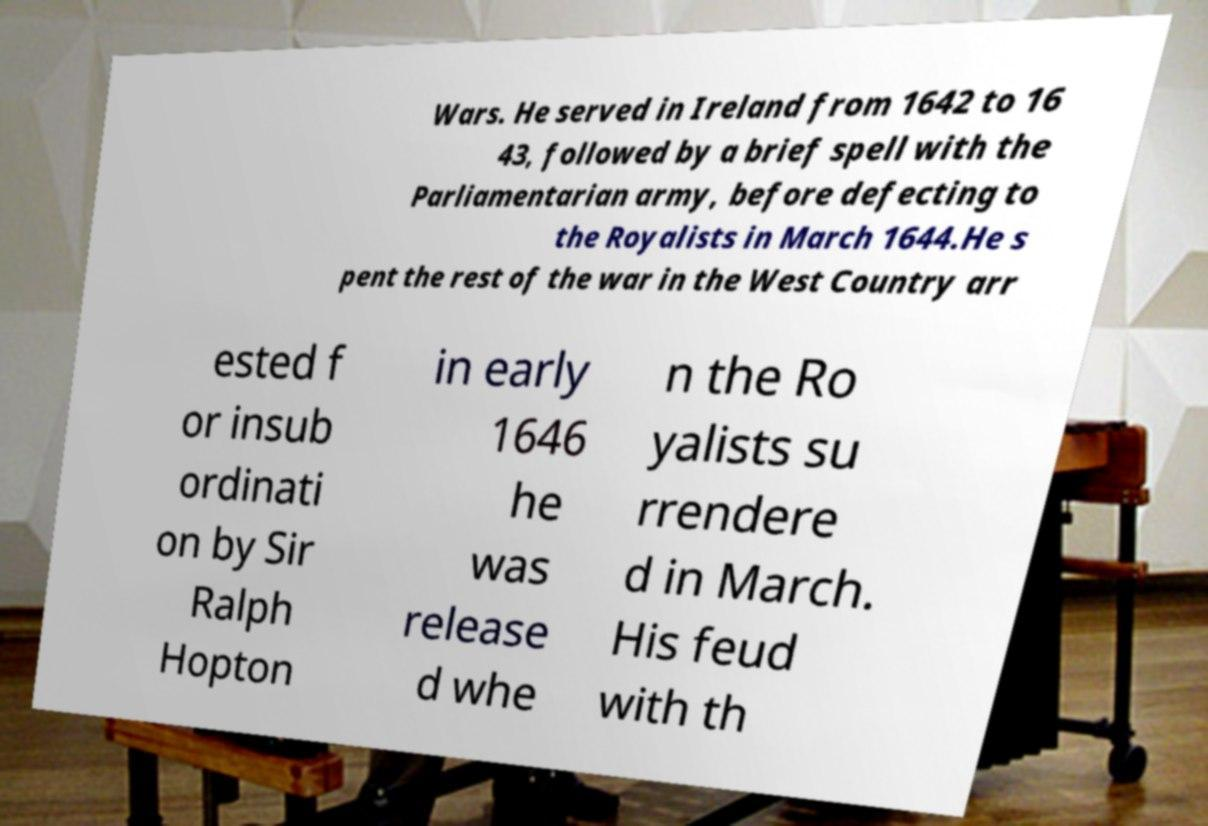Could you extract and type out the text from this image? Wars. He served in Ireland from 1642 to 16 43, followed by a brief spell with the Parliamentarian army, before defecting to the Royalists in March 1644.He s pent the rest of the war in the West Country arr ested f or insub ordinati on by Sir Ralph Hopton in early 1646 he was release d whe n the Ro yalists su rrendere d in March. His feud with th 